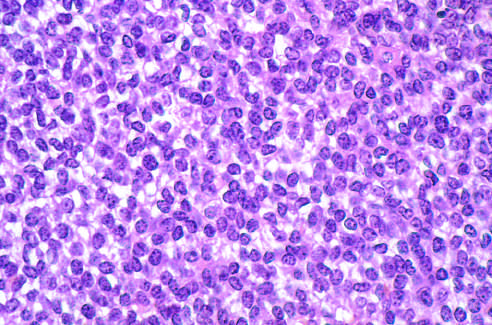what is composed of sheets of small round cells with small amounts of clear cytoplasm?
Answer the question using a single word or phrase. Ewing sarcoma 